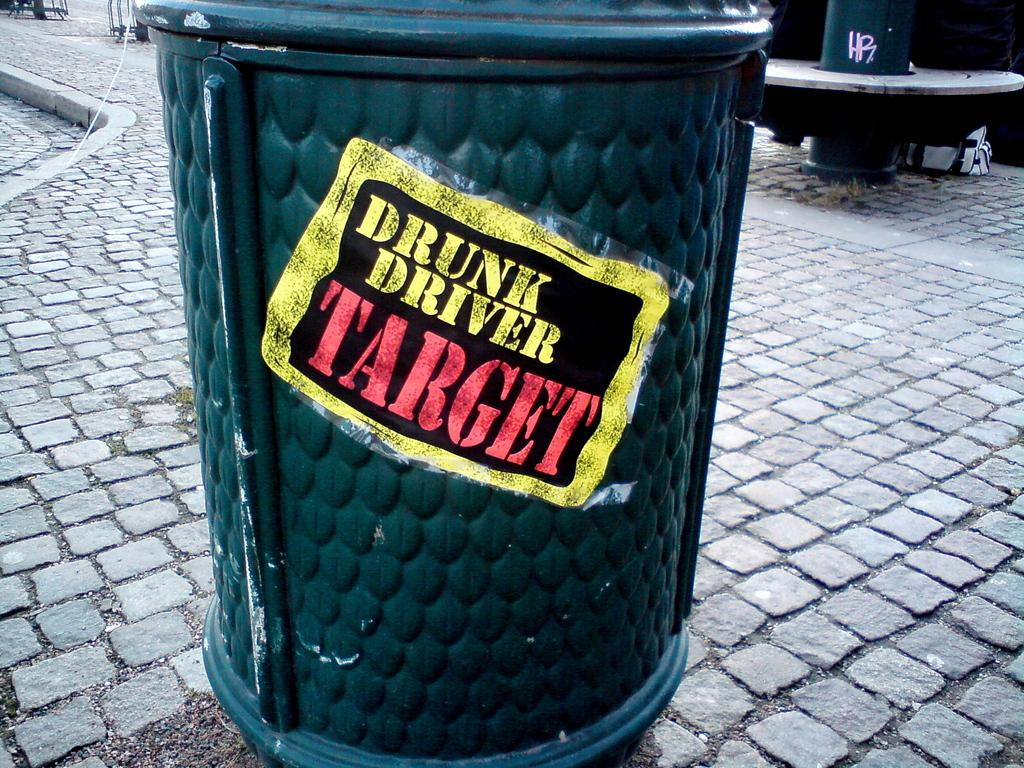<image>
Render a clear and concise summary of the photo. A outdoor waste bin that reads, "Drunk Driver Target". 